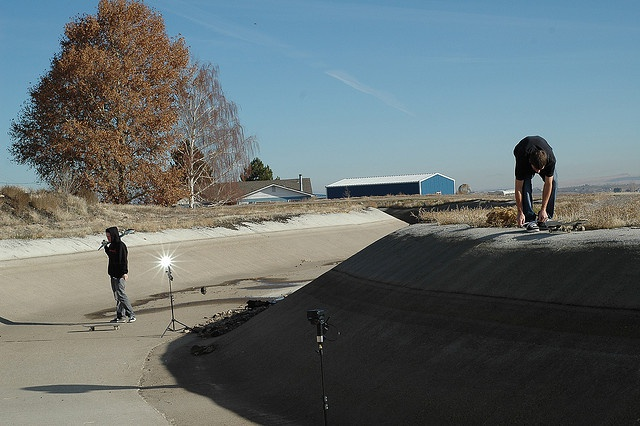Describe the objects in this image and their specific colors. I can see people in gray, black, darkgray, and maroon tones, people in gray, black, darkgray, and maroon tones, skateboard in gray, black, and darkgray tones, and skateboard in gray, darkgray, and black tones in this image. 